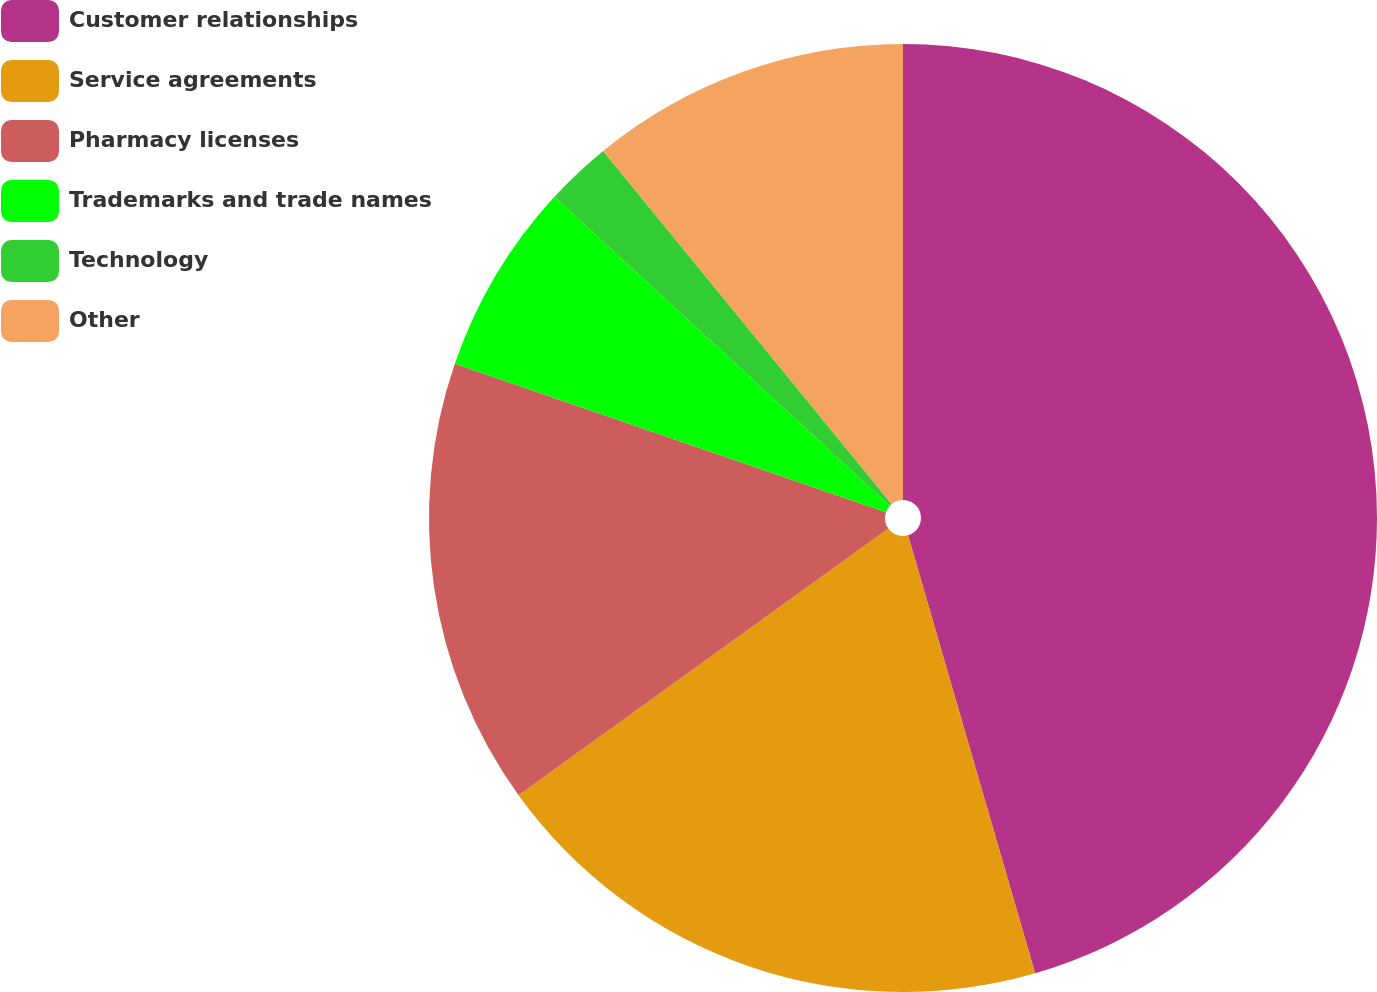Convert chart. <chart><loc_0><loc_0><loc_500><loc_500><pie_chart><fcel>Customer relationships<fcel>Service agreements<fcel>Pharmacy licenses<fcel>Trademarks and trade names<fcel>Technology<fcel>Other<nl><fcel>45.5%<fcel>19.55%<fcel>15.22%<fcel>6.57%<fcel>2.25%<fcel>10.9%<nl></chart> 